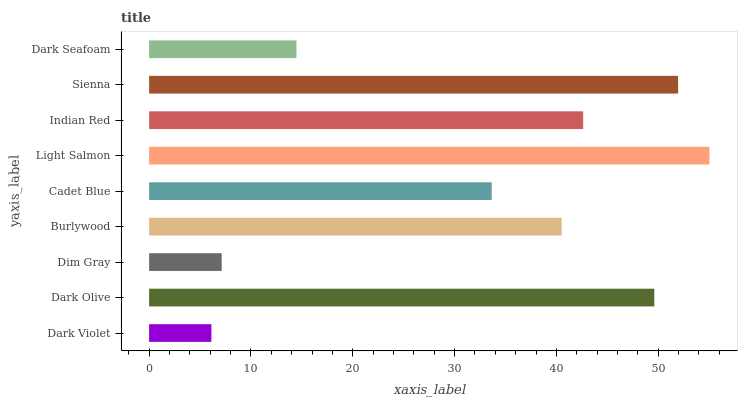Is Dark Violet the minimum?
Answer yes or no. Yes. Is Light Salmon the maximum?
Answer yes or no. Yes. Is Dark Olive the minimum?
Answer yes or no. No. Is Dark Olive the maximum?
Answer yes or no. No. Is Dark Olive greater than Dark Violet?
Answer yes or no. Yes. Is Dark Violet less than Dark Olive?
Answer yes or no. Yes. Is Dark Violet greater than Dark Olive?
Answer yes or no. No. Is Dark Olive less than Dark Violet?
Answer yes or no. No. Is Burlywood the high median?
Answer yes or no. Yes. Is Burlywood the low median?
Answer yes or no. Yes. Is Dark Seafoam the high median?
Answer yes or no. No. Is Dark Seafoam the low median?
Answer yes or no. No. 